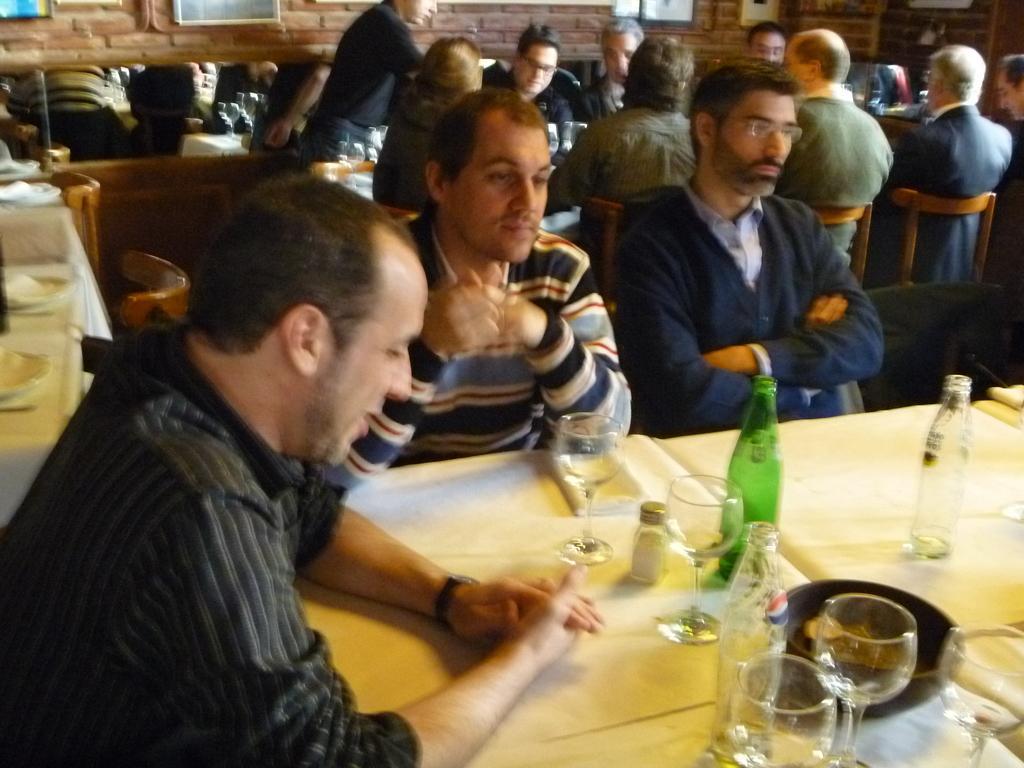Could you give a brief overview of what you see in this image? There are many persons sitting in this room. There are many chairs in this room. There is one table. On this table there are bottles, glasses, bowl. In the background there is a brick wall. 